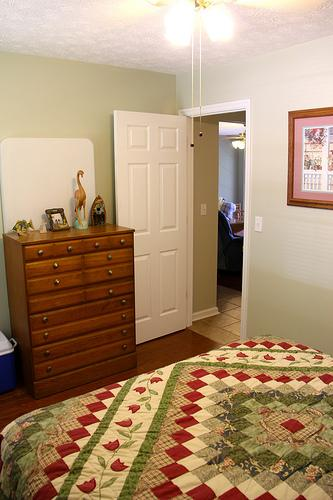What is the main piece of furniture in the room, and what is on top of it? A wooden dresser with brass knobs, and dinosaur models on top. List two objects that are blue in the image. A blue cooler with a white lid and a blue armchair. What types of items are used for decoration in the image? A fish figurine, a picture with a pink matte and wooden frame, a golden frame, and a decorative bird. What type of fan is present in the room, and where is it located? A ceiling fan with light fixtures, located on the ceiling. Briefly describe the flooring in the room. A brown wooden floor and beige tile flooring. What kind of bedspread is on the bed in the image, and what are its primary colors? A patchwork quilt with red flowers, green and red quilted bedspread. Which kind of switch is present on the wall, and what is its color? A white light switch with a white face plate. Identify the type of room featured in the image. A small American-style bedroom. Describe the condition of the door in the image and its color. An open white bedroom door with rectangle shapes on it. What is a person doing in the image, and where are they located? A man is sitting in the other room, reading. Identify the features of a wooden dresser in the bedroom. Brown, multiple drawers, brass knobs, and silver knobs What items are on top of the dresser? Dinosaur models, knick knacks, figurine, bird, fish figurine What is the color of the cooler in the image? Blue and white Could you tell whether someone is performing any action in the next room? Yes, a man is sitting and reading What material is the door made of? Wood What type of flooring is seen in the image? Hard wood floor and beige tile flooring Describe the appearance of the light switch in the room. White face plate What style of decor is present in the bedroom? Simple American Choose the correct description for the quilt on the bed: a) Quilt with red flowers b) Gray plain quilt c) Striped colorful quilt Quilt with red flowers Identify the main pieces of furniture in this image. Dresser, bed, blue armchair Which of these objects can be found on the dresser? Figurine, golden frame, fish figurine Can you find the blue quilt with red flowers in the image? The quilt in the image is described as "patch work quilt bead spread" and "flowered quilt on bed" with red patches, but it is not specifically mentioned as blue. Can you spot the black ceiling fan without lamps? The ceiling fan in the image is described as "ceiling fan with lamps" and "ceiling fan with light fixtures", so it has lamps and there is no mention of its color being black. Is the bedroom door open or closed? Open What type of landscapes are surrounding the objects? A small bedroom What type of decorations are present in the bedroom? Simple American bedroom decor Is there a white wooden dresser with brass knobs in the bedroom? The dresser in the image is described as "wooden dresser", "wooden chest of drawers with brass knobs" and "brown dresser with silver knobs", but it is not specifically mentioned as being white. Do you see a man standing in the other room cooking? The person in the image is described as "man sitting in the other room reading", so he is sitting, not standing, and he is reading, not cooking. What color is the armchair? Blue What is the content of the picture in the wooden frame? Not provided in the given information Does the ceiling fan have lamps? Yes Is there a framed picture of a yellow matte and wooden frame on the wall? The framed picture in the image is described as "a picture with a pink matte and wooden frame" and "wooden picture frame holding a picture", so it has a pink matte, not a yellow one. Find an object made of plastic in the image. Blue cooler with a white lid Can you find a green armchair in the room? The armchair in the image is described as "blue armchair" and "blue recliner in room", so it is blue, not green. What activity is the man in the other room engaged in? Reading 